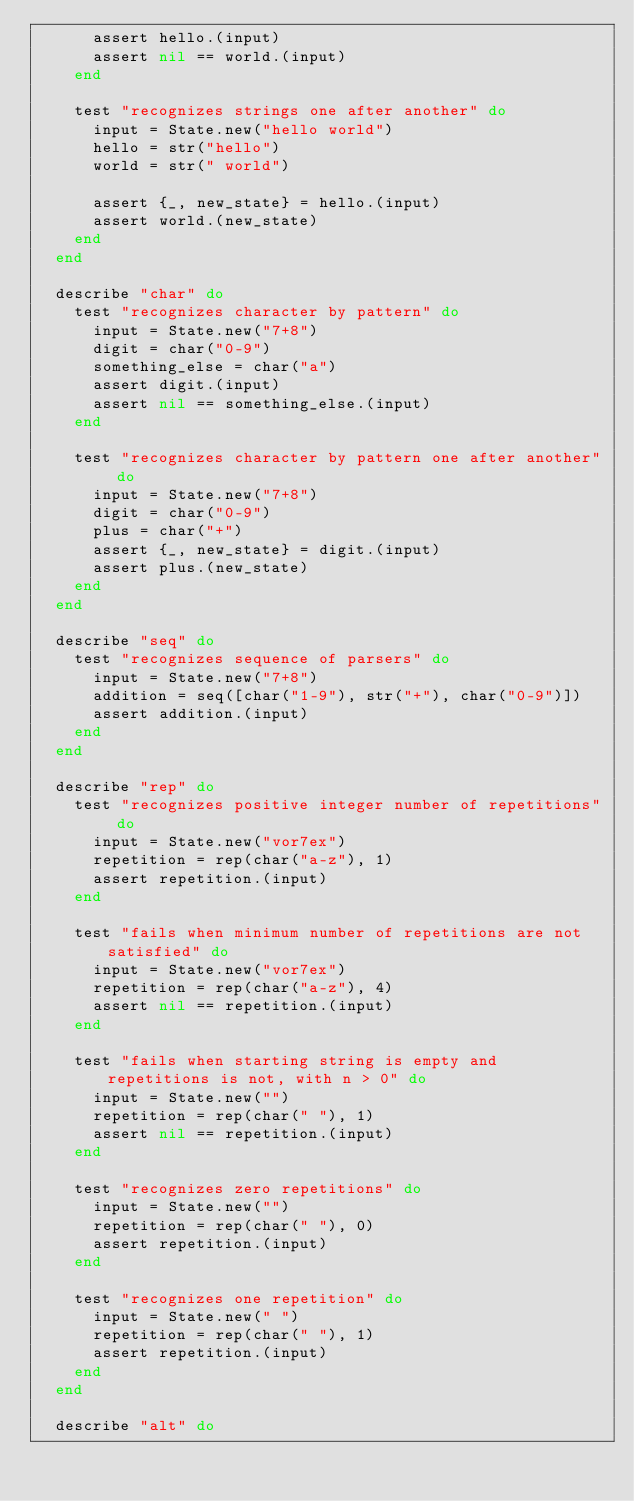<code> <loc_0><loc_0><loc_500><loc_500><_Elixir_>      assert hello.(input)
      assert nil == world.(input)
    end

    test "recognizes strings one after another" do
      input = State.new("hello world")
      hello = str("hello")
      world = str(" world")

      assert {_, new_state} = hello.(input)
      assert world.(new_state)
    end
  end

  describe "char" do
    test "recognizes character by pattern" do
      input = State.new("7+8")
      digit = char("0-9")
      something_else = char("a")
      assert digit.(input)
      assert nil == something_else.(input)
    end

    test "recognizes character by pattern one after another" do
      input = State.new("7+8")
      digit = char("0-9")
      plus = char("+")
      assert {_, new_state} = digit.(input)
      assert plus.(new_state)
    end
  end

  describe "seq" do
    test "recognizes sequence of parsers" do
      input = State.new("7+8")
      addition = seq([char("1-9"), str("+"), char("0-9")])
      assert addition.(input)
    end
  end

  describe "rep" do
    test "recognizes positive integer number of repetitions" do
      input = State.new("vor7ex")
      repetition = rep(char("a-z"), 1)
      assert repetition.(input)
    end

    test "fails when minimum number of repetitions are not satisfied" do
      input = State.new("vor7ex")
      repetition = rep(char("a-z"), 4)
      assert nil == repetition.(input)
    end

    test "fails when starting string is empty and repetitions is not, with n > 0" do
      input = State.new("")
      repetition = rep(char(" "), 1)
      assert nil == repetition.(input)
    end

    test "recognizes zero repetitions" do
      input = State.new("")
      repetition = rep(char(" "), 0)
      assert repetition.(input)
    end

    test "recognizes one repetition" do
      input = State.new(" ")
      repetition = rep(char(" "), 1)
      assert repetition.(input)
    end
  end

  describe "alt" do</code> 